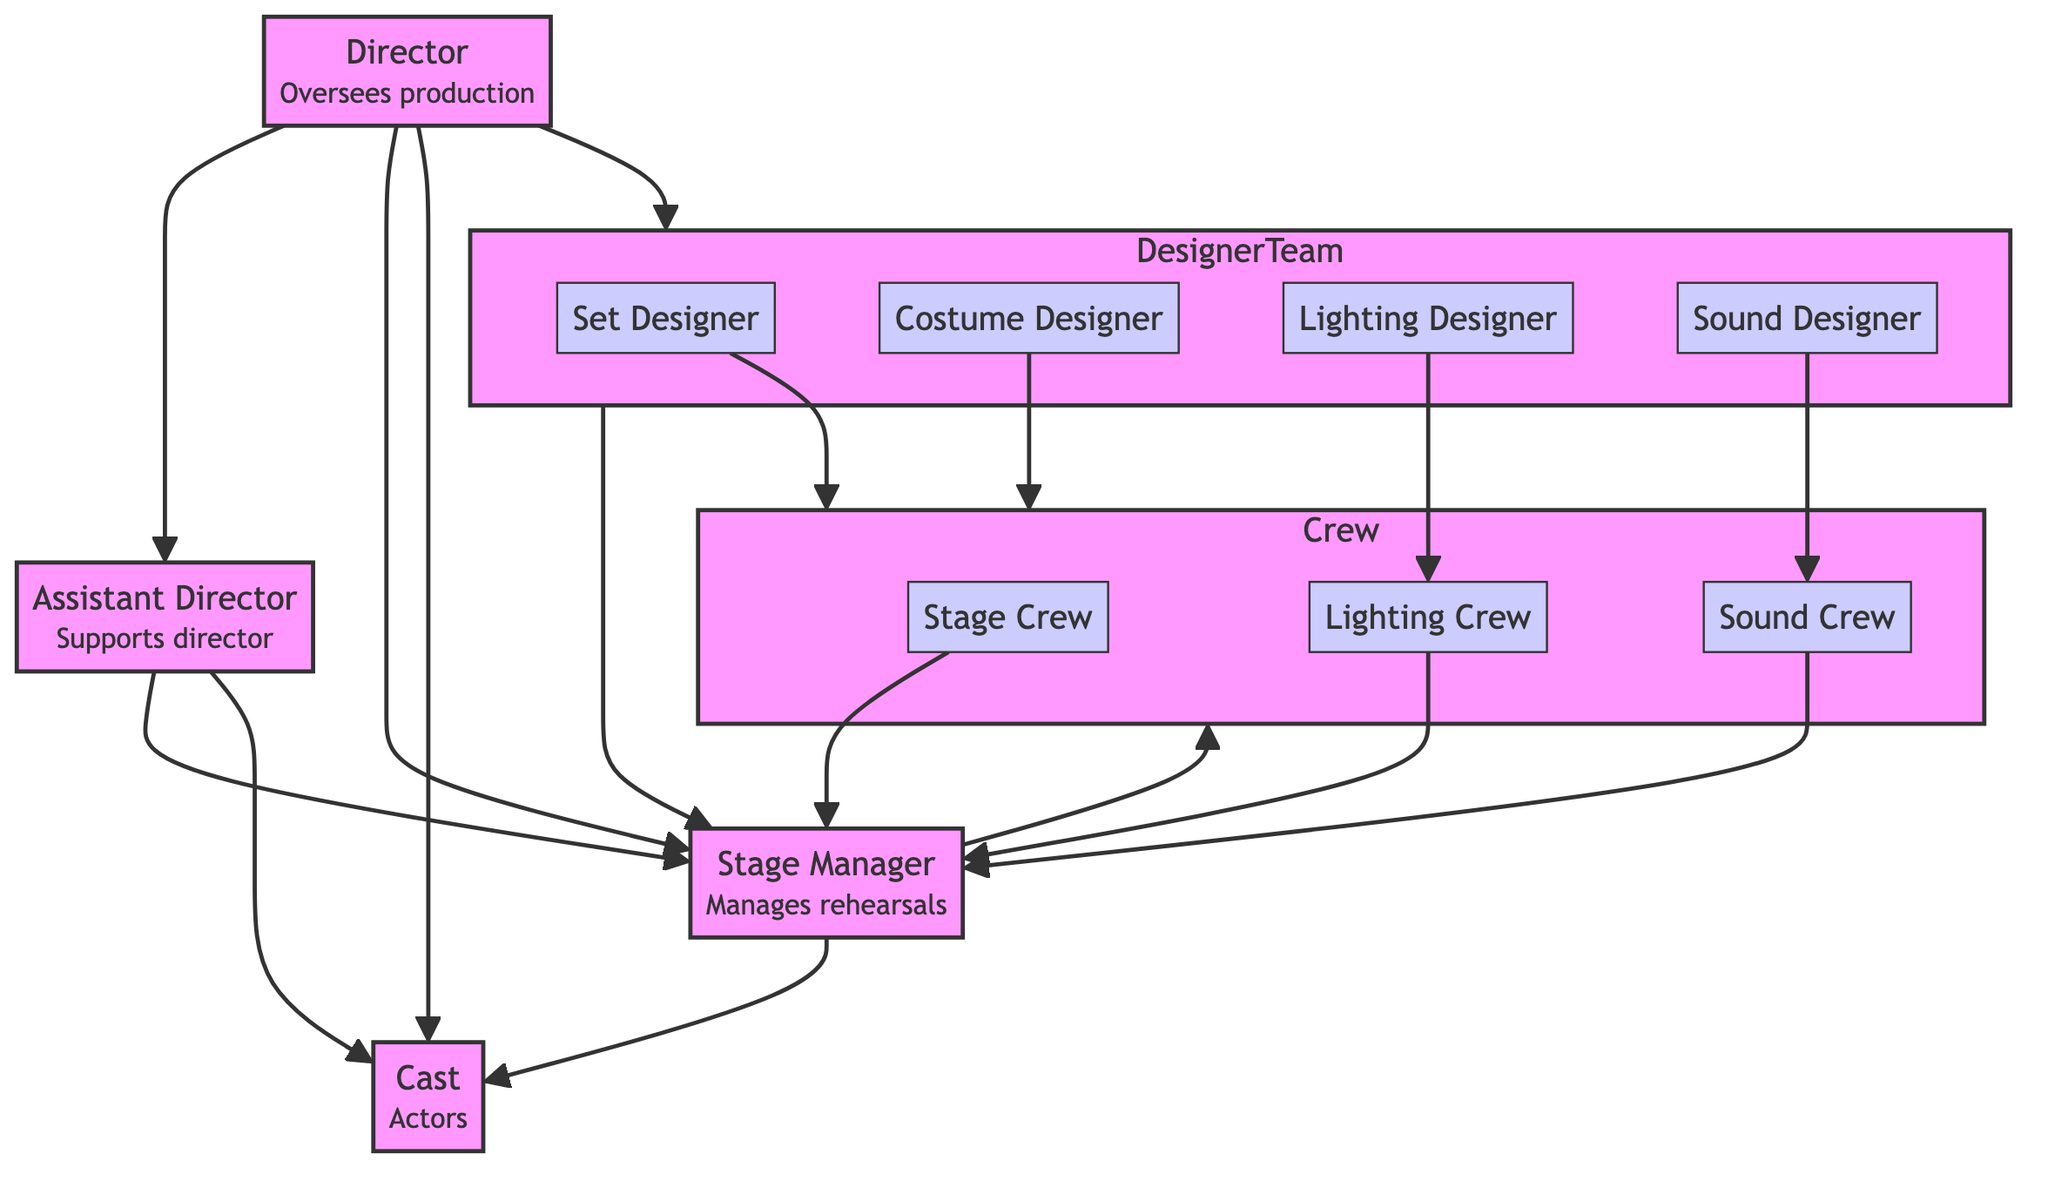What is the role of the Director? The Director oversees the entire production and makes final artistic decisions, as outlined in the diagram near the Director node.
Answer: Oversees production How many connections does the Assistant Director have? By counting the arrows leading from the Assistant Director node, I see there are three connections: to the Director, Stage Manager, and Cast.
Answer: 3 Who does the Crew report to? The Crew reports to the Stage Manager, as indicated by the arrows connecting the Crew node to the Stage Manager node in the diagram.
Answer: Stage Manager What is the focus of the Set Designer? The Set Designer's focus is on creating the physical surroundings for the action to take place, which is explicitly stated in the description next to the Set Designer node.
Answer: Creates physical surroundings Which role directly supports the Director? The role that directly supports the Director is the Assistant Director, shown by a direct connection (arrow) from the Director node to the Assistant Director node in the diagram.
Answer: Assistant Director How many sub-roles are included in the Designer Team? The Designer Team consists of four sub-roles: Set Designer, Costume Designer, Lighting Designer, and Sound Designer. I counted these nodes within the Designer Team subgraph.
Answer: 4 What is the relationship between the Stage Manager and the Cast? The relationship is that the Stage Manager manages the rehearsals and coordinates communication, as indicated by the direct connection from the Stage Manager node to the Cast node in the diagram.
Answer: Manages rehearsals What is the role of the Lighting Crew? The role of the Lighting Crew is to execute the lighting plan, which is specified in the Lighting Crew node description.
Answer: Execute lighting plan Who does the Sound Designer collaborate with? The Sound Designer collaborates with the Sound Crew and the Stage Manager, as indicated by the arrows connecting the Sound Designer node to both the Sound Crew node and the Stage Manager node.
Answer: Sound Crew, Stage Manager What overall function does the Designer Team serve in the production? The Designer Team is responsible for set design, costume design, lighting design, and sound design, as detailed in the role description of the Designer Team node.
Answer: Responsible for design aspects 